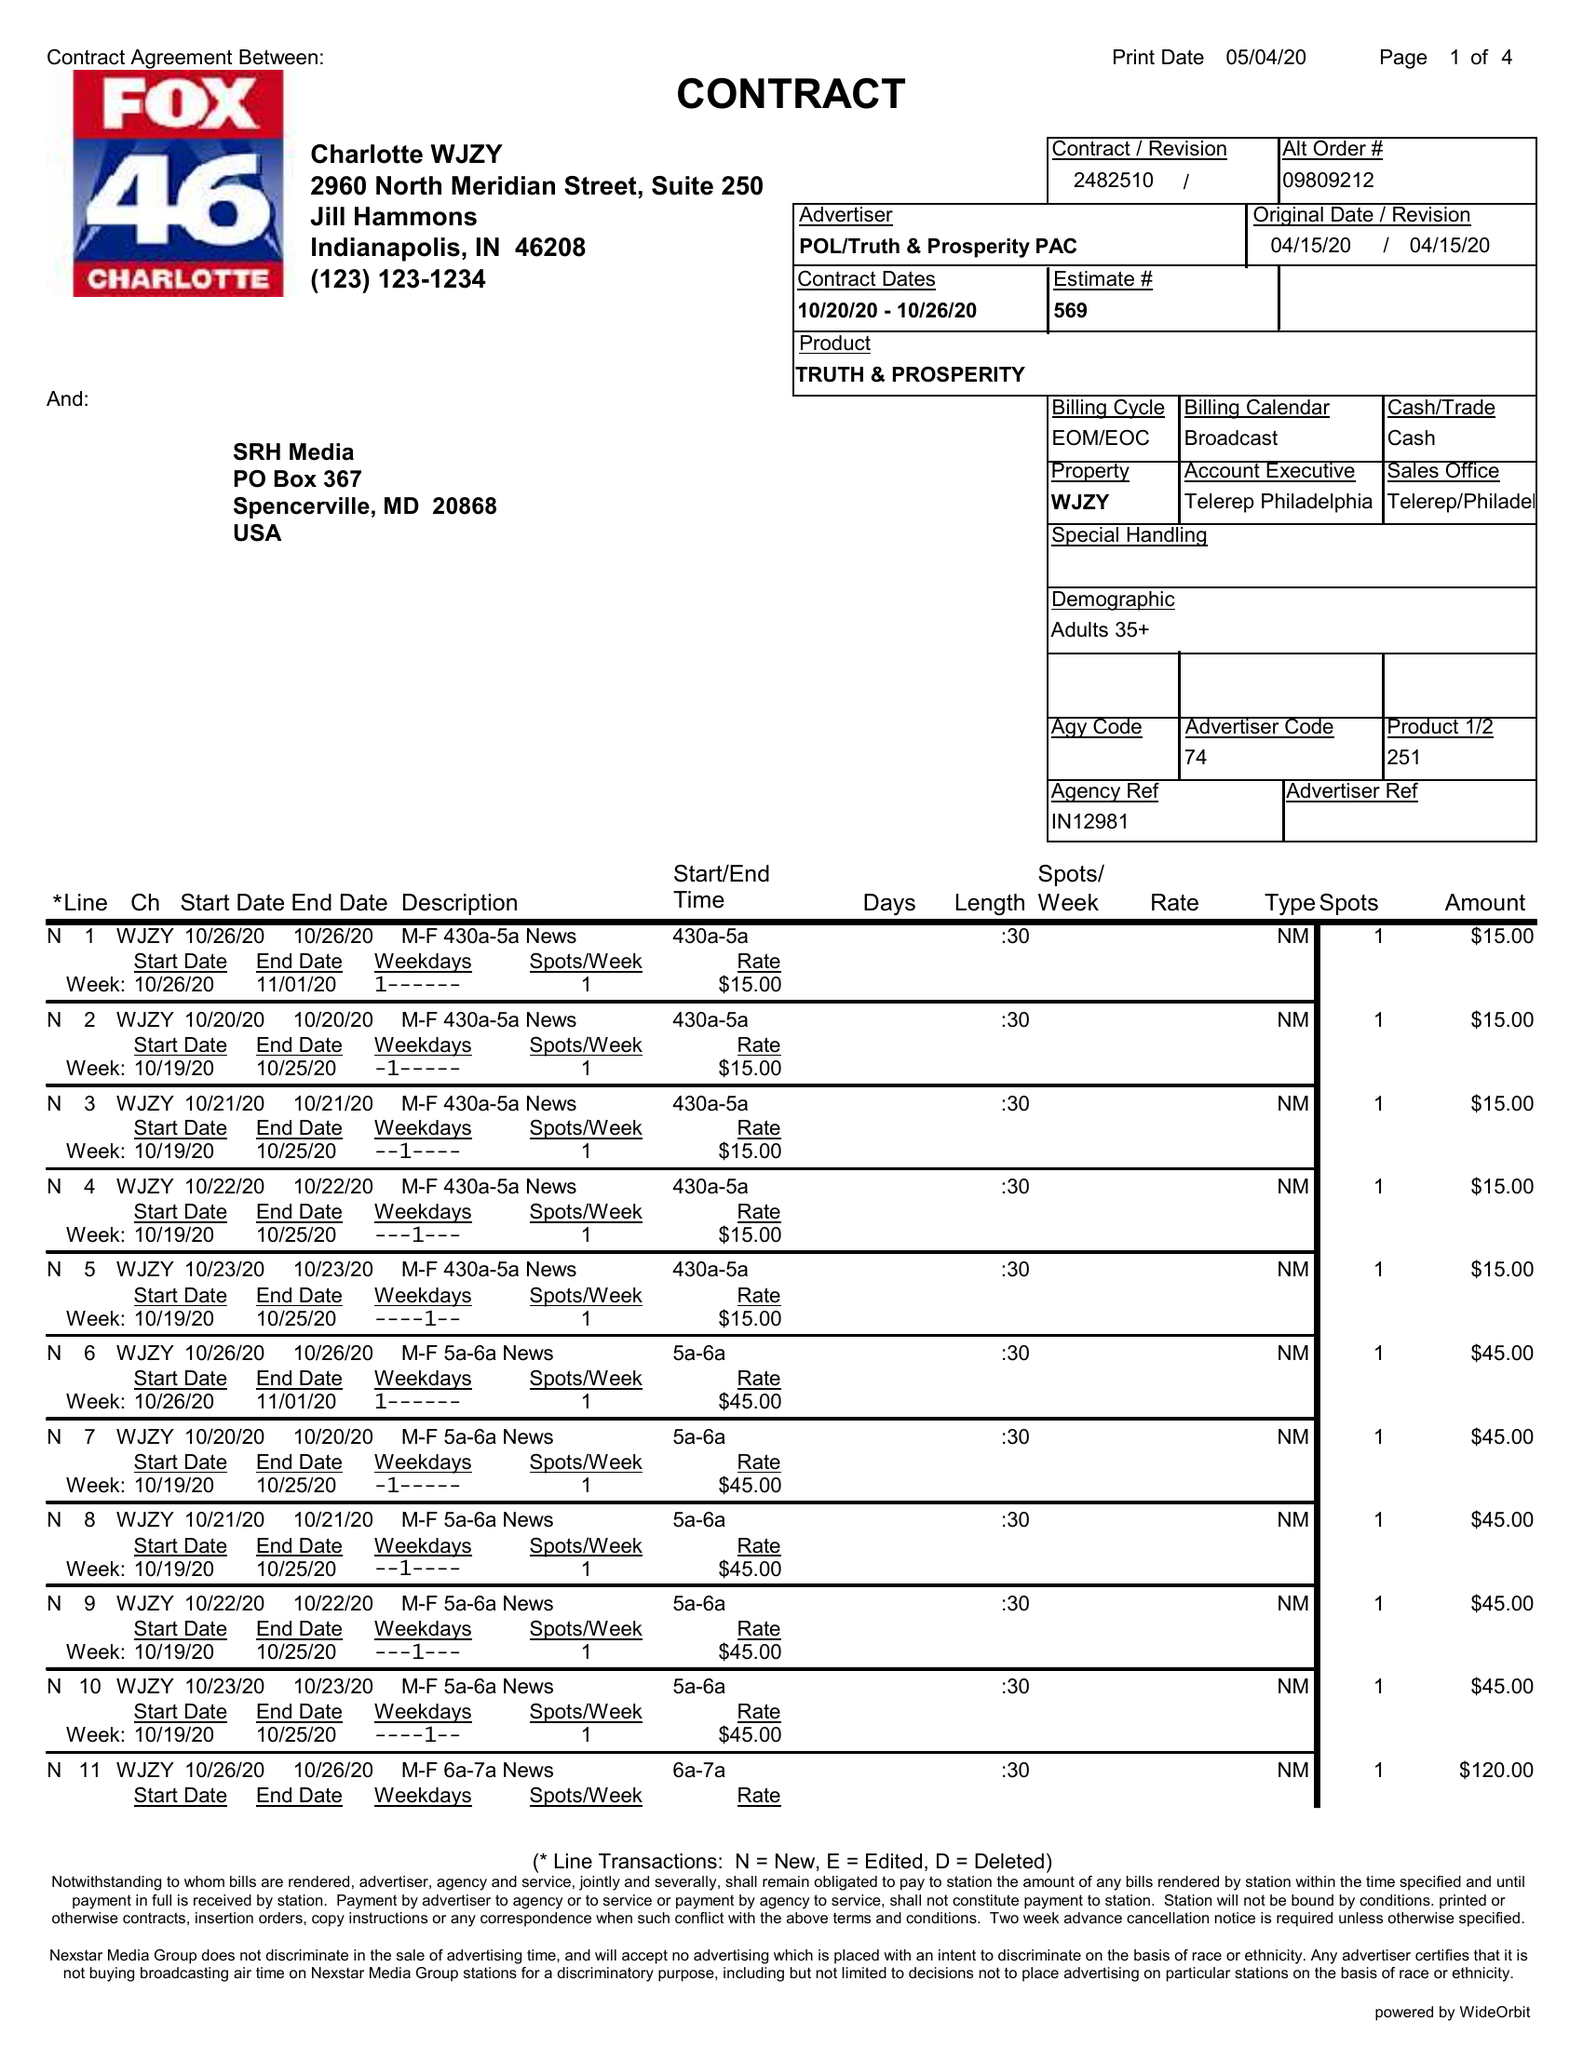What is the value for the flight_from?
Answer the question using a single word or phrase. 10/20/20 